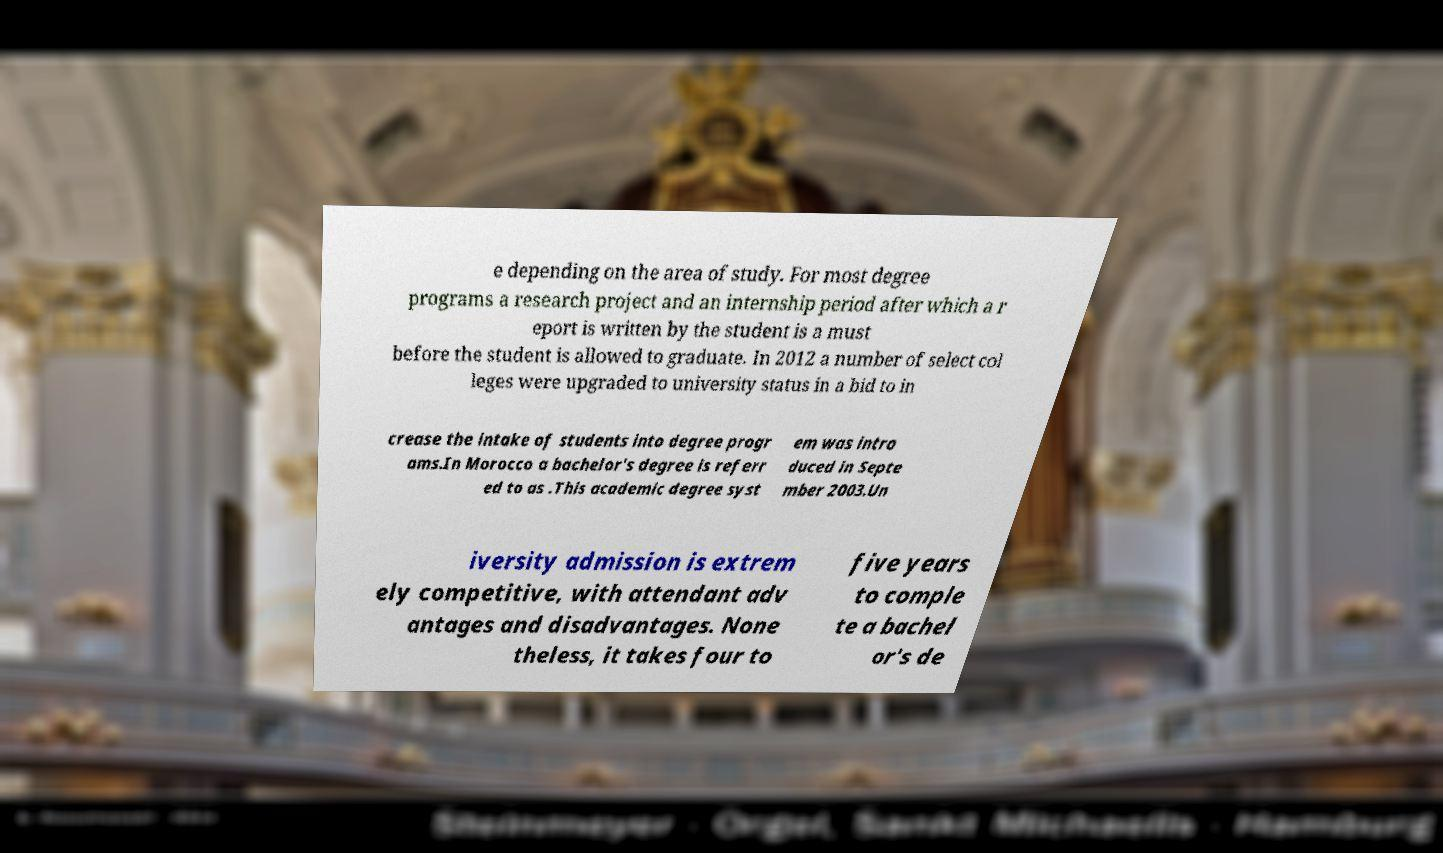Please read and relay the text visible in this image. What does it say? e depending on the area of study. For most degree programs a research project and an internship period after which a r eport is written by the student is a must before the student is allowed to graduate. In 2012 a number of select col leges were upgraded to university status in a bid to in crease the intake of students into degree progr ams.In Morocco a bachelor's degree is referr ed to as .This academic degree syst em was intro duced in Septe mber 2003.Un iversity admission is extrem ely competitive, with attendant adv antages and disadvantages. None theless, it takes four to five years to comple te a bachel or's de 